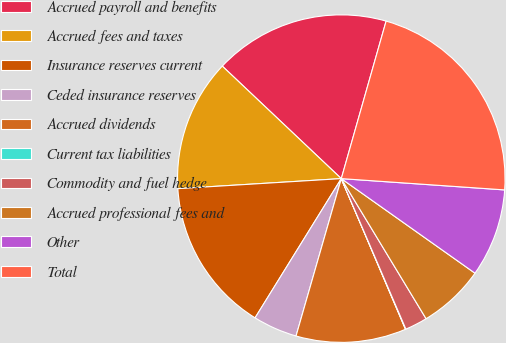Convert chart to OTSL. <chart><loc_0><loc_0><loc_500><loc_500><pie_chart><fcel>Accrued payroll and benefits<fcel>Accrued fees and taxes<fcel>Insurance reserves current<fcel>Ceded insurance reserves<fcel>Accrued dividends<fcel>Current tax liabilities<fcel>Commodity and fuel hedge<fcel>Accrued professional fees and<fcel>Other<fcel>Total<nl><fcel>17.36%<fcel>13.03%<fcel>15.2%<fcel>4.37%<fcel>10.87%<fcel>0.04%<fcel>2.21%<fcel>6.54%<fcel>8.7%<fcel>21.69%<nl></chart> 